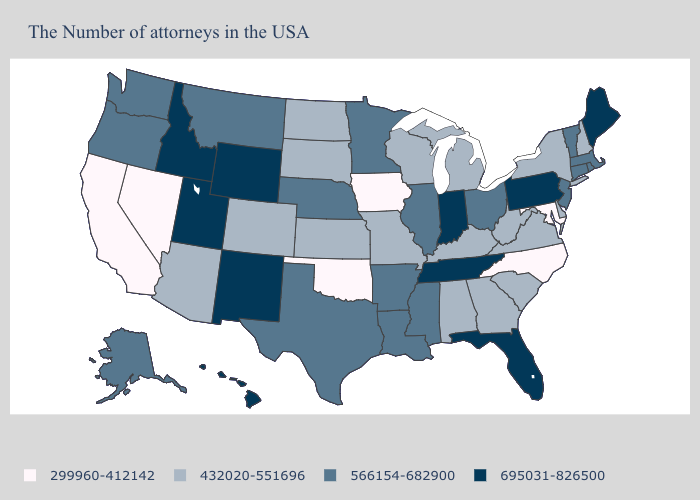What is the lowest value in the Northeast?
Write a very short answer. 432020-551696. What is the lowest value in the Northeast?
Write a very short answer. 432020-551696. What is the lowest value in the USA?
Concise answer only. 299960-412142. Which states have the highest value in the USA?
Short answer required. Maine, Pennsylvania, Florida, Indiana, Tennessee, Wyoming, New Mexico, Utah, Idaho, Hawaii. What is the value of New Jersey?
Give a very brief answer. 566154-682900. Name the states that have a value in the range 432020-551696?
Short answer required. New Hampshire, New York, Delaware, Virginia, South Carolina, West Virginia, Georgia, Michigan, Kentucky, Alabama, Wisconsin, Missouri, Kansas, South Dakota, North Dakota, Colorado, Arizona. What is the value of Nebraska?
Be succinct. 566154-682900. What is the value of West Virginia?
Write a very short answer. 432020-551696. What is the lowest value in the USA?
Short answer required. 299960-412142. Does Georgia have the same value as Texas?
Quick response, please. No. Does Georgia have the same value as Washington?
Quick response, please. No. Does Ohio have the same value as Delaware?
Answer briefly. No. What is the highest value in the Northeast ?
Concise answer only. 695031-826500. What is the value of Idaho?
Write a very short answer. 695031-826500. What is the value of Colorado?
Keep it brief. 432020-551696. 